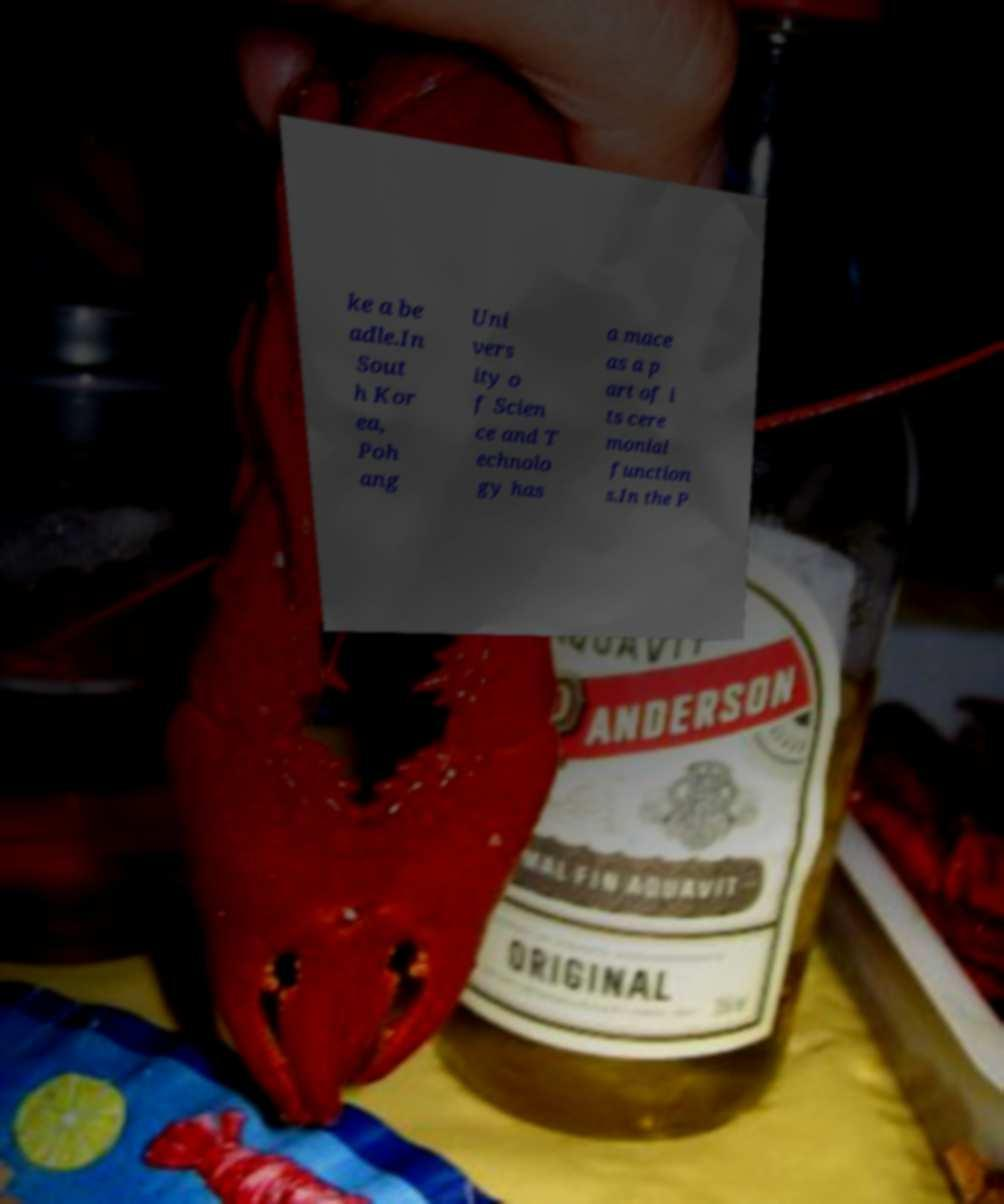Please identify and transcribe the text found in this image. ke a be adle.In Sout h Kor ea, Poh ang Uni vers ity o f Scien ce and T echnolo gy has a mace as a p art of i ts cere monial function s.In the P 